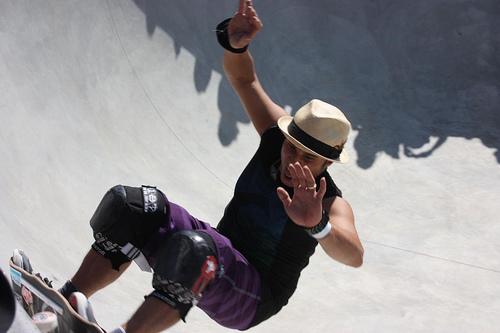Is the man in motion?
Quick response, please. Yes. Is it sunny?
Keep it brief. Yes. What are the black objects on the man's knees?
Answer briefly. Knee pads. 